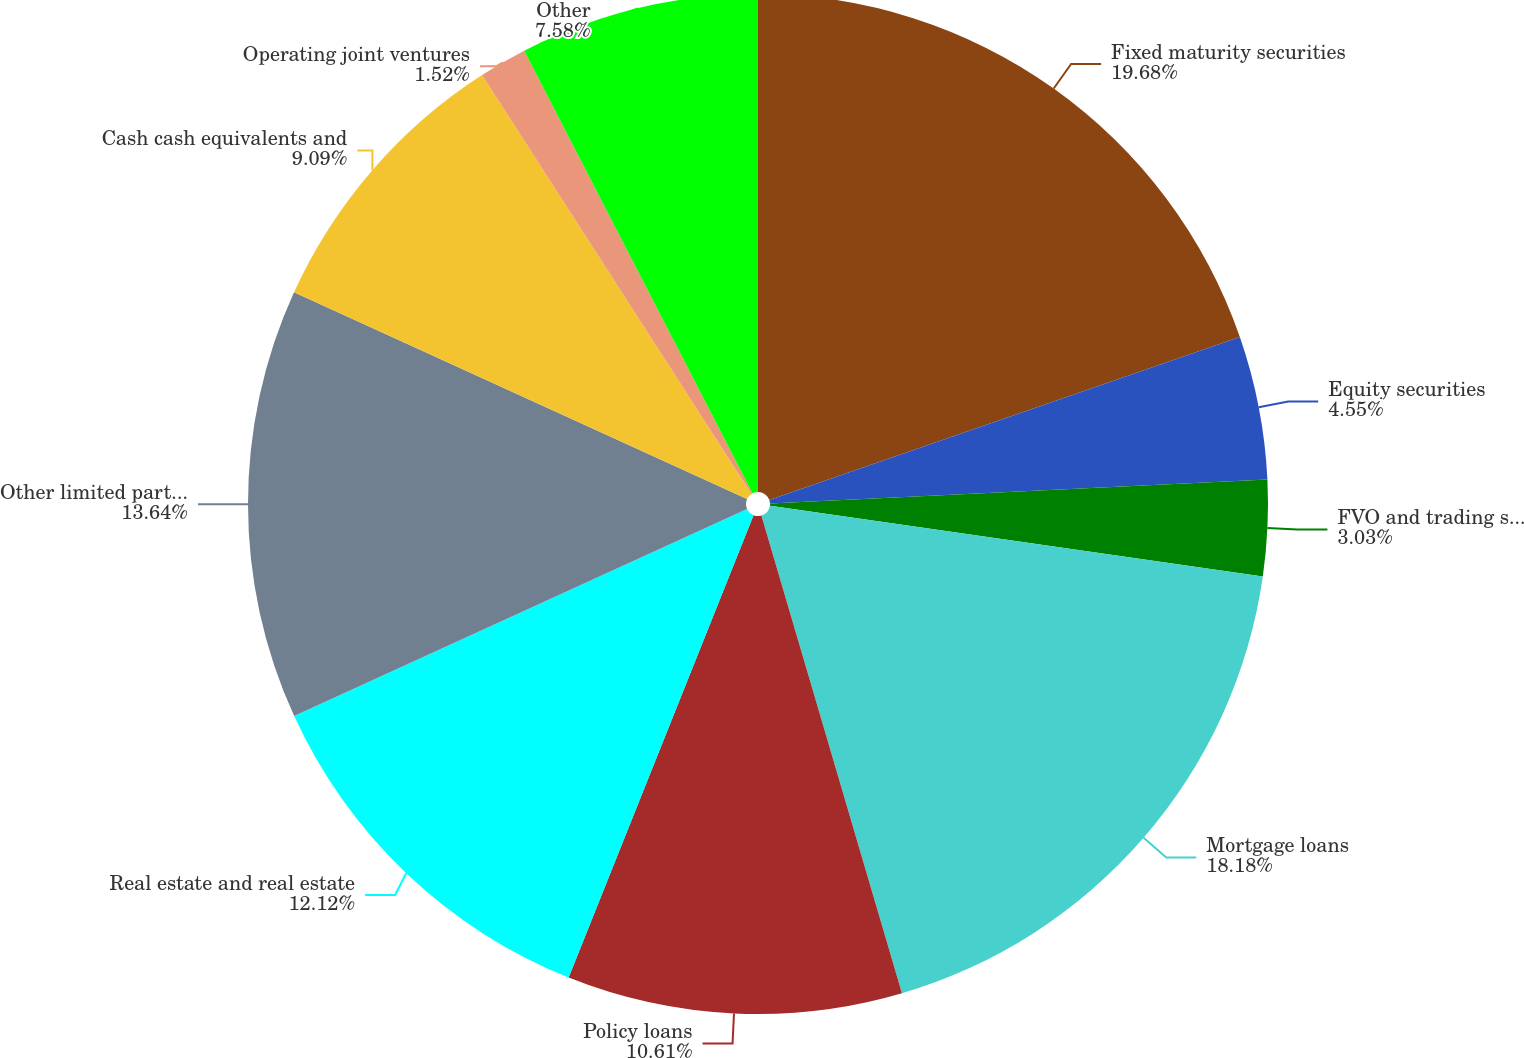Convert chart. <chart><loc_0><loc_0><loc_500><loc_500><pie_chart><fcel>Fixed maturity securities<fcel>Equity securities<fcel>FVO and trading securities -<fcel>Mortgage loans<fcel>Policy loans<fcel>Real estate and real estate<fcel>Other limited partnership<fcel>Cash cash equivalents and<fcel>Operating joint ventures<fcel>Other<nl><fcel>19.69%<fcel>4.55%<fcel>3.03%<fcel>18.18%<fcel>10.61%<fcel>12.12%<fcel>13.64%<fcel>9.09%<fcel>1.52%<fcel>7.58%<nl></chart> 